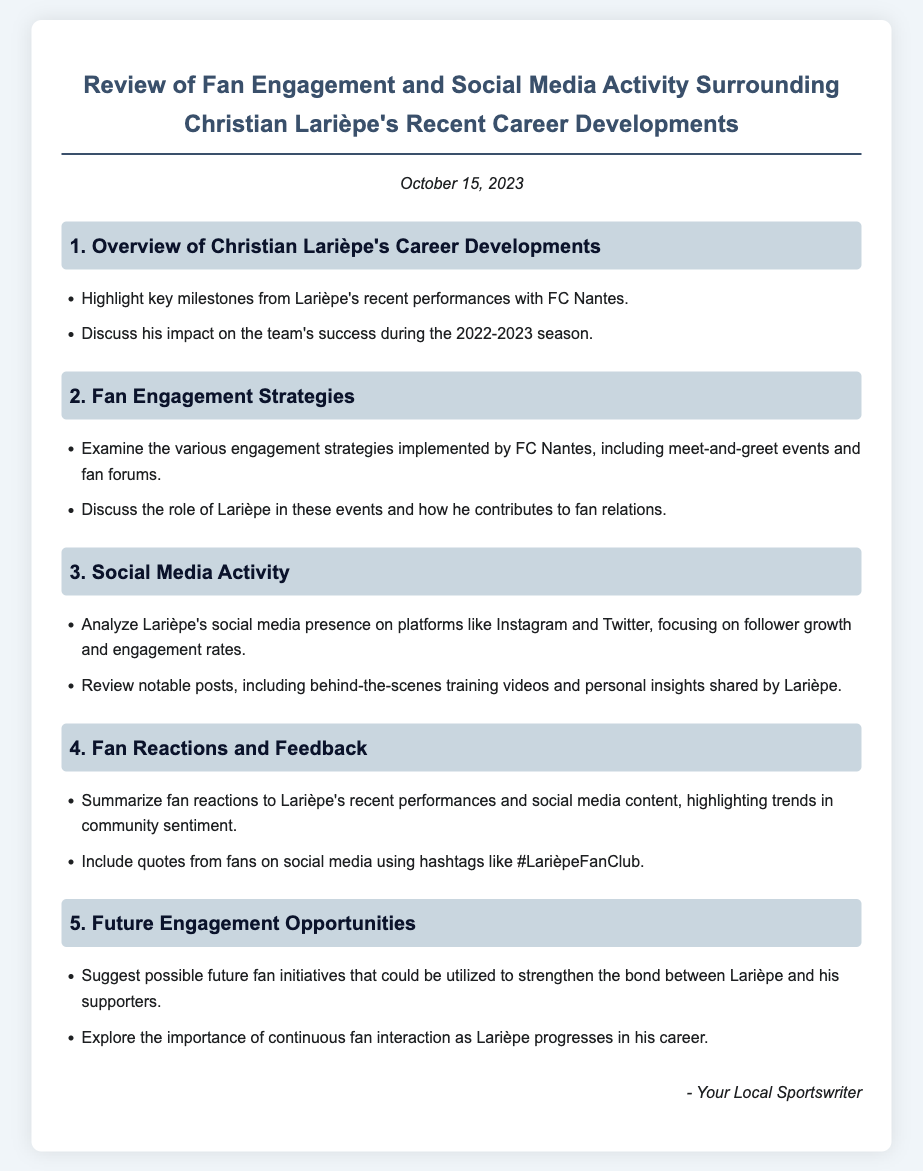What date was the review published? The review was published on October 15, 2023.
Answer: October 15, 2023 What team did Christian Larièpe recently perform with? Larièpe's recent performances are highlighted with FC Nantes.
Answer: FC Nantes What is one of the social media platforms analyzed in the document? The document mentions Larièpe's social media presence on Instagram.
Answer: Instagram What engagement strategies were implemented by FC Nantes? The document discusses various engagement strategies, including meet-and-greet events.
Answer: meet-and-greet events What hashtag is associated with fan feedback on social media? The document includes fan quotes using the hashtag #LarièpeFanClub.
Answer: #LarièpeFanClub What impact did Larièpe have on the team's success? The document discusses his impact during the 2022-2023 season.
Answer: 2022-2023 season What type of content did Larièpe share on social media? The review mentions notable posts including behind-the-scenes training videos.
Answer: behind-the-scenes training videos What is suggested as a future engagement opportunity? The document suggests possible future fan initiatives to strengthen the bond between Larièpe and his supporters.
Answer: future fan initiatives 